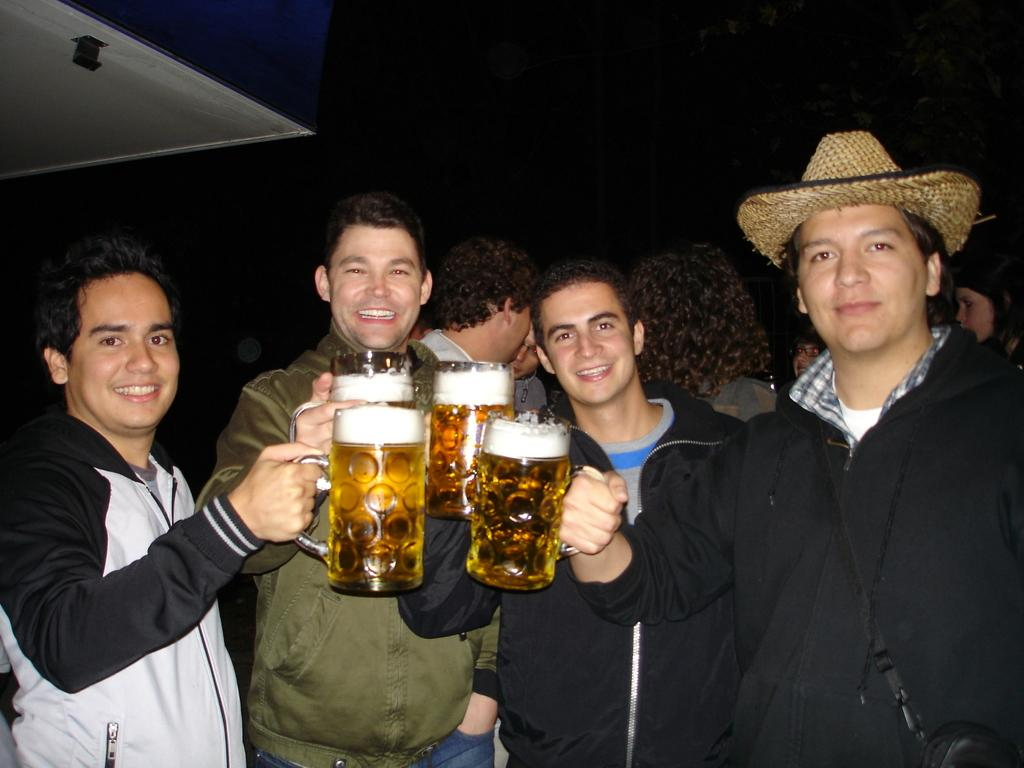How many men are in the image? There are four men in the image. What are the men holding in their hands? The men are holding glasses with drinks in them. What is the facial expression of the men in the image? The men are smiling. What can be seen in the background of the image? There is a wall and other people in the background of the image. How would you describe the lighting in the image? The background is dark. Can you see a knot tied on the stove in the image? There is no stove or knot present in the image. What type of frog is sitting on the shoulder of one of the men in the image? There are no frogs present in the image. 